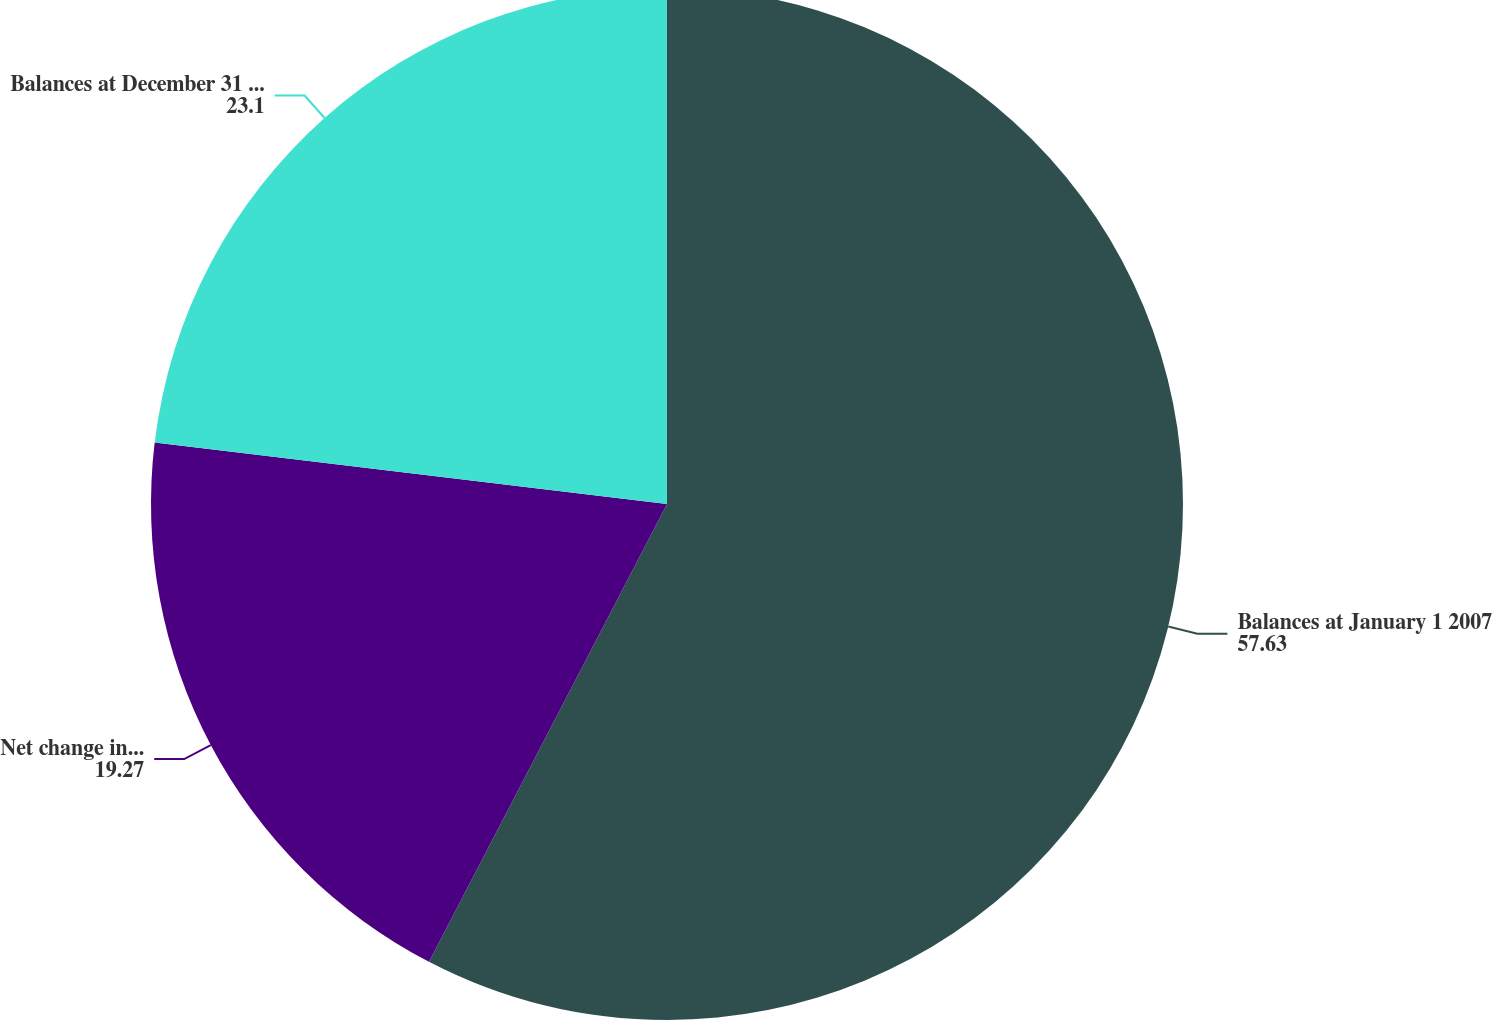Convert chart to OTSL. <chart><loc_0><loc_0><loc_500><loc_500><pie_chart><fcel>Balances at January 1 2007<fcel>Net change in provision for<fcel>Balances at December 31 2007<nl><fcel>57.63%<fcel>19.27%<fcel>23.1%<nl></chart> 